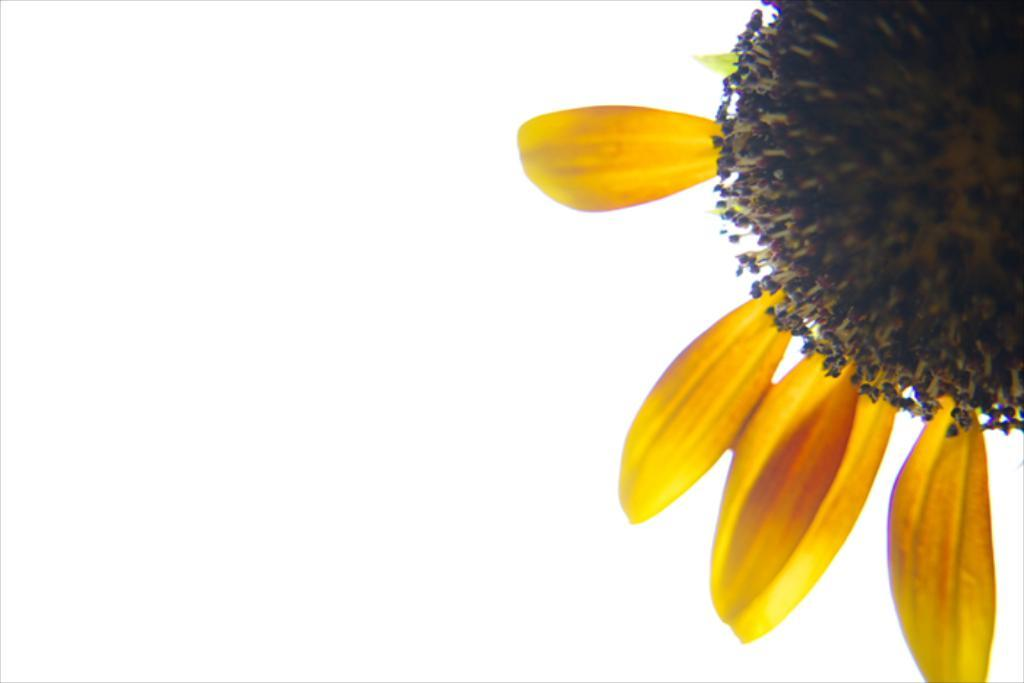What type of plant is in the image? There is a sunflower in the image. How many petals does the sunflower have? The sunflower has few petals. What type of brake is used to stop the sunflower from moving? There is no brake present in the image, as the sunflower is a stationary plant. 